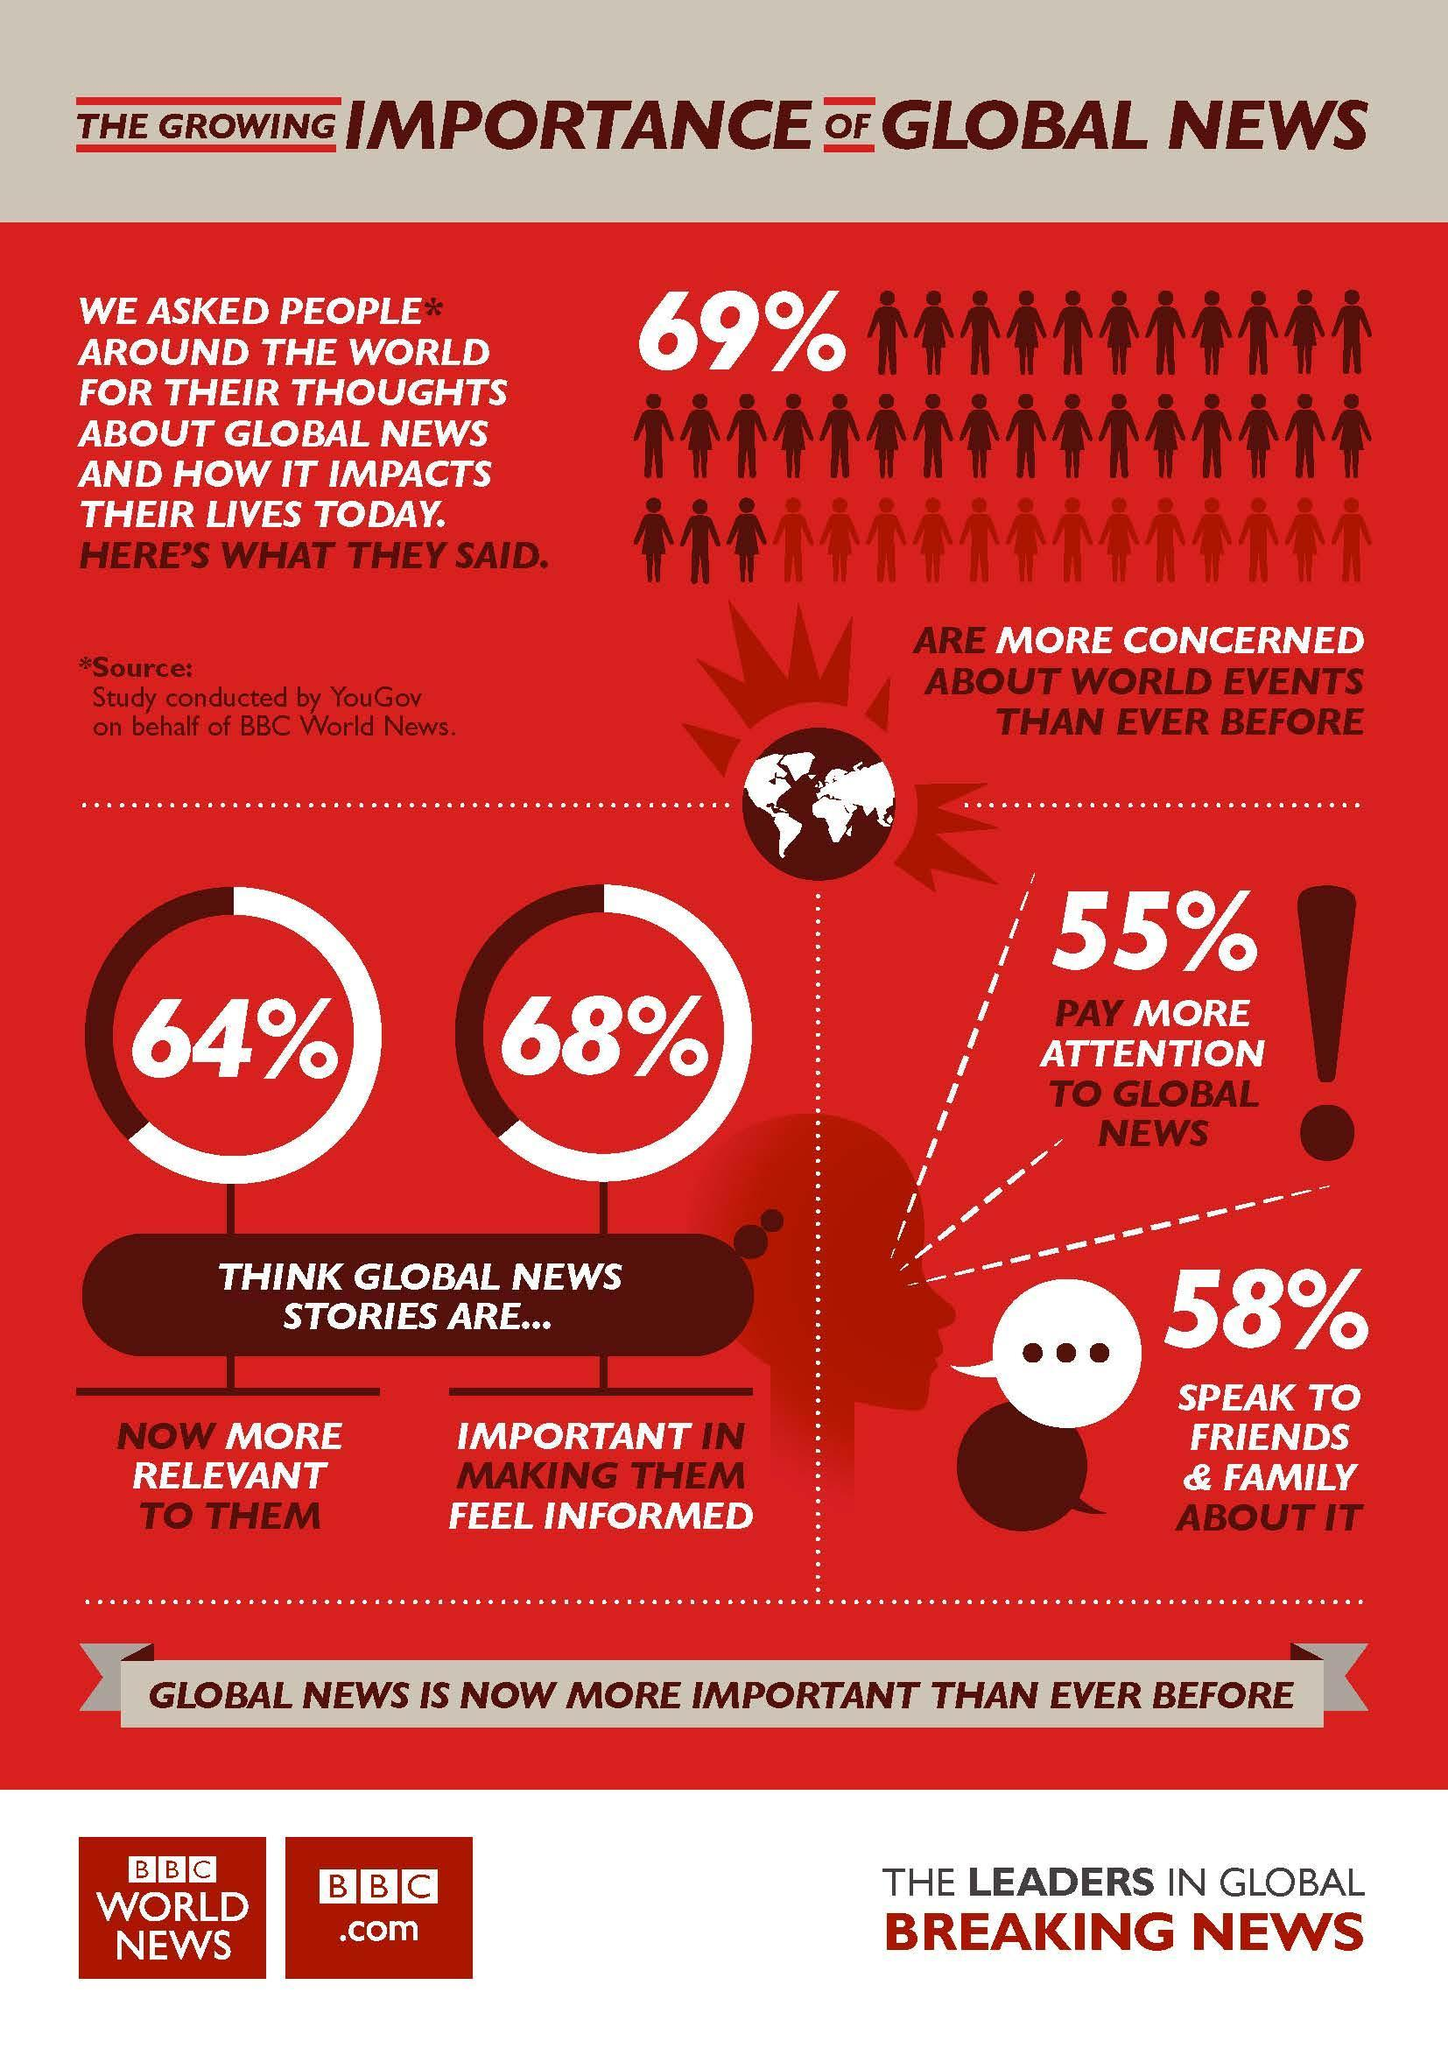What percentage of people think that global news stories are important in making them feel informed according to the study conducted by YouGov on behalf of BBC World News?
Answer the question with a short phrase. 68% What percentage of people do not pay more attention to global news according to the study conducted by YouGov on behalf of BBC World News? 45% 